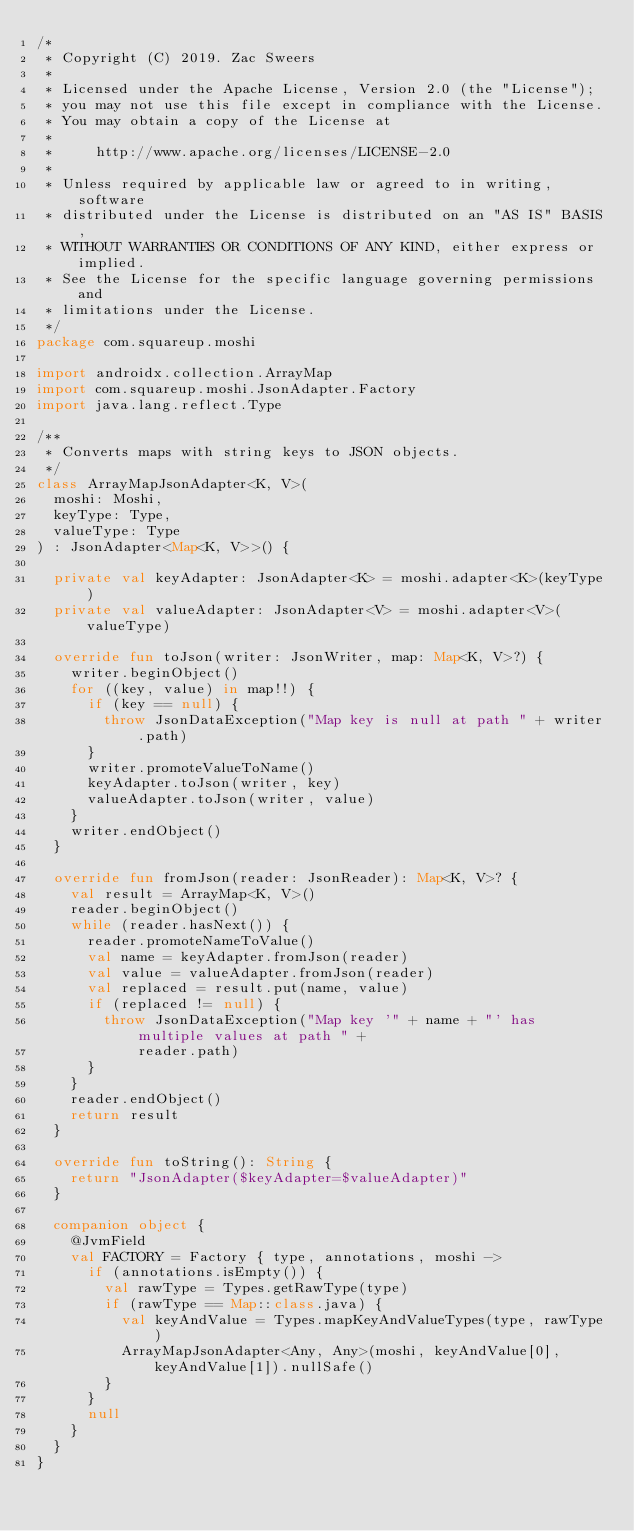Convert code to text. <code><loc_0><loc_0><loc_500><loc_500><_Kotlin_>/*
 * Copyright (C) 2019. Zac Sweers
 *
 * Licensed under the Apache License, Version 2.0 (the "License");
 * you may not use this file except in compliance with the License.
 * You may obtain a copy of the License at
 *
 *     http://www.apache.org/licenses/LICENSE-2.0
 *
 * Unless required by applicable law or agreed to in writing, software
 * distributed under the License is distributed on an "AS IS" BASIS,
 * WITHOUT WARRANTIES OR CONDITIONS OF ANY KIND, either express or implied.
 * See the License for the specific language governing permissions and
 * limitations under the License.
 */
package com.squareup.moshi

import androidx.collection.ArrayMap
import com.squareup.moshi.JsonAdapter.Factory
import java.lang.reflect.Type

/**
 * Converts maps with string keys to JSON objects.
 */
class ArrayMapJsonAdapter<K, V>(
  moshi: Moshi,
  keyType: Type,
  valueType: Type
) : JsonAdapter<Map<K, V>>() {

  private val keyAdapter: JsonAdapter<K> = moshi.adapter<K>(keyType)
  private val valueAdapter: JsonAdapter<V> = moshi.adapter<V>(valueType)

  override fun toJson(writer: JsonWriter, map: Map<K, V>?) {
    writer.beginObject()
    for ((key, value) in map!!) {
      if (key == null) {
        throw JsonDataException("Map key is null at path " + writer.path)
      }
      writer.promoteValueToName()
      keyAdapter.toJson(writer, key)
      valueAdapter.toJson(writer, value)
    }
    writer.endObject()
  }

  override fun fromJson(reader: JsonReader): Map<K, V>? {
    val result = ArrayMap<K, V>()
    reader.beginObject()
    while (reader.hasNext()) {
      reader.promoteNameToValue()
      val name = keyAdapter.fromJson(reader)
      val value = valueAdapter.fromJson(reader)
      val replaced = result.put(name, value)
      if (replaced != null) {
        throw JsonDataException("Map key '" + name + "' has multiple values at path " +
            reader.path)
      }
    }
    reader.endObject()
    return result
  }

  override fun toString(): String {
    return "JsonAdapter($keyAdapter=$valueAdapter)"
  }

  companion object {
    @JvmField
    val FACTORY = Factory { type, annotations, moshi ->
      if (annotations.isEmpty()) {
        val rawType = Types.getRawType(type)
        if (rawType == Map::class.java) {
          val keyAndValue = Types.mapKeyAndValueTypes(type, rawType)
          ArrayMapJsonAdapter<Any, Any>(moshi, keyAndValue[0], keyAndValue[1]).nullSafe()
        }
      }
      null
    }
  }
}
</code> 